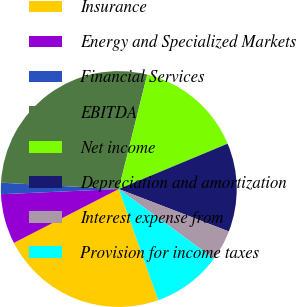Convert chart. <chart><loc_0><loc_0><loc_500><loc_500><pie_chart><fcel>Insurance<fcel>Energy and Specialized Markets<fcel>Financial Services<fcel>EBITDA<fcel>Net income<fcel>Depreciation and amortization<fcel>Interest expense from<fcel>Provision for income taxes<nl><fcel>22.88%<fcel>6.85%<fcel>1.56%<fcel>28.02%<fcel>14.84%<fcel>12.14%<fcel>4.21%<fcel>9.5%<nl></chart> 